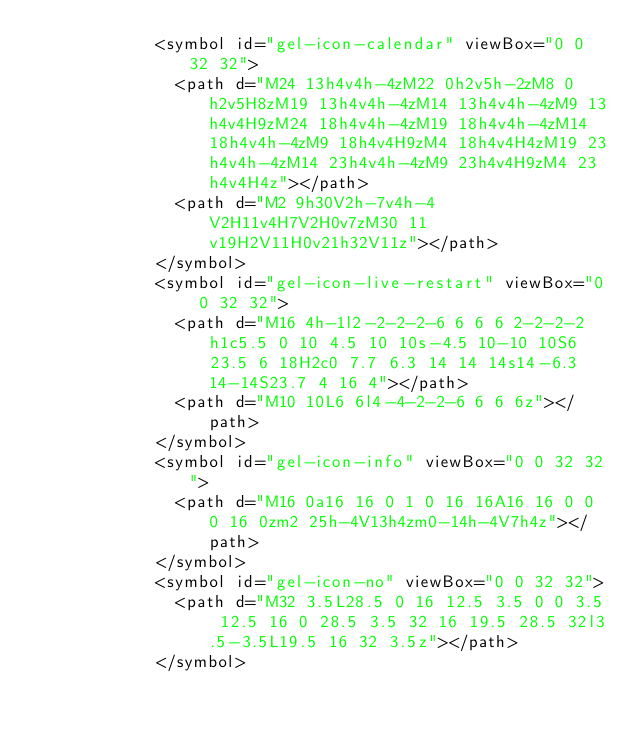<code> <loc_0><loc_0><loc_500><loc_500><_HTML_>            <symbol id="gel-icon-calendar" viewBox="0 0 32 32">
              <path d="M24 13h4v4h-4zM22 0h2v5h-2zM8 0h2v5H8zM19 13h4v4h-4zM14 13h4v4h-4zM9 13h4v4H9zM24 18h4v4h-4zM19 18h4v4h-4zM14 18h4v4h-4zM9 18h4v4H9zM4 18h4v4H4zM19 23h4v4h-4zM14 23h4v4h-4zM9 23h4v4H9zM4 23h4v4H4z"></path>
              <path d="M2 9h30V2h-7v4h-4V2H11v4H7V2H0v7zM30 11v19H2V11H0v21h32V11z"></path>
            </symbol>
            <symbol id="gel-icon-live-restart" viewBox="0 0 32 32">
              <path d="M16 4h-1l2-2-2-2-6 6 6 6 2-2-2-2h1c5.5 0 10 4.5 10 10s-4.5 10-10 10S6 23.5 6 18H2c0 7.7 6.3 14 14 14s14-6.3 14-14S23.7 4 16 4"></path>
              <path d="M10 10L6 6l4-4-2-2-6 6 6 6z"></path>
            </symbol>
            <symbol id="gel-icon-info" viewBox="0 0 32 32">
              <path d="M16 0a16 16 0 1 0 16 16A16 16 0 0 0 16 0zm2 25h-4V13h4zm0-14h-4V7h4z"></path>
            </symbol>
            <symbol id="gel-icon-no" viewBox="0 0 32 32">
              <path d="M32 3.5L28.5 0 16 12.5 3.5 0 0 3.5 12.5 16 0 28.5 3.5 32 16 19.5 28.5 32l3.5-3.5L19.5 16 32 3.5z"></path>
            </symbol></code> 